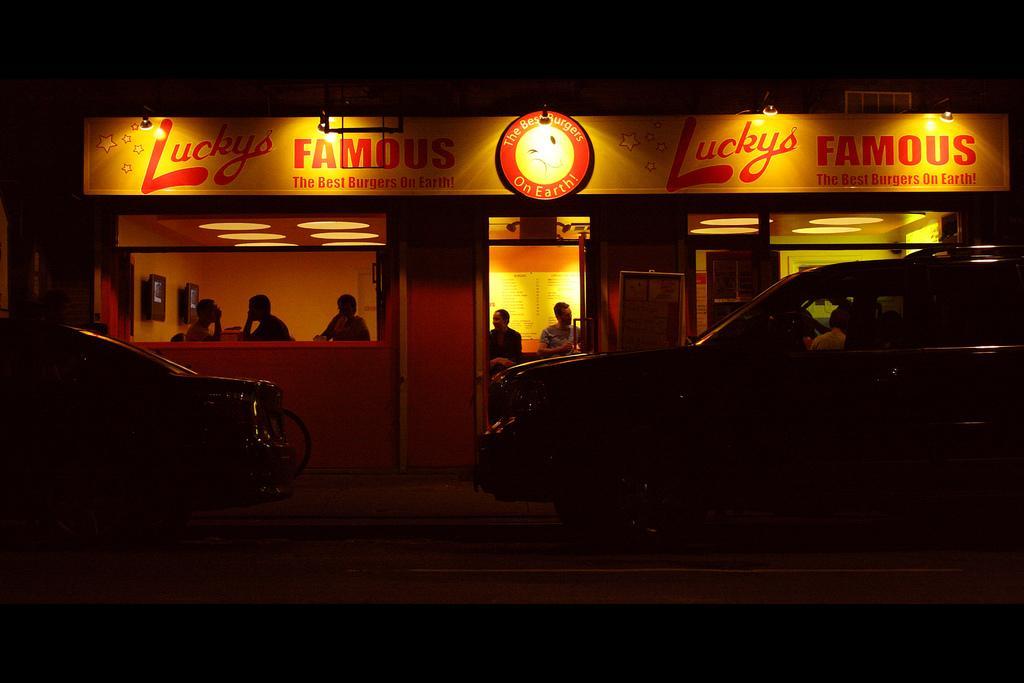Describe this image in one or two sentences. In this image I can see out side view of a building and there are some vehicles kept on the floor and in side the building there are the persons visible and there is a hoarding board on the building and there is a s some text written on that. 